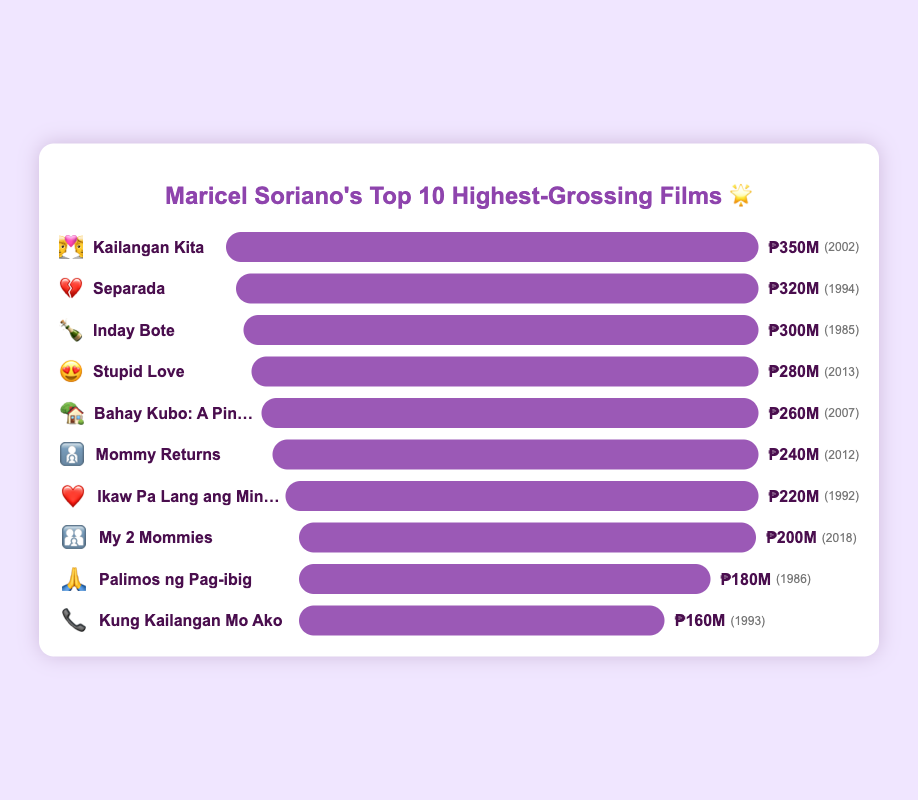Which film has the highest box office gross? The film with the highest box office gross is identified by the longest bar. "Kailangan Kita" has the longest bar with an adjusted gross of ₱350M.
Answer: "Kailangan Kita" Which film was released in 2013, and what is its box office gross? Look for the film that displays the emoji 😍 and check its gross. "Stupid Love" was released in 2013 and its gross is ₱280M.
Answer: "Stupid Love" with ₱280M Which films grossed more than ₱300M? Identify the films with bars extending beyond the ₱300M mark or whose adjusted gross values are greater than ₱300M. The films "Kailangan Kita" (₱350M), "Separada" (₱320M), and "Inday Bote" (₱300M) are the ones.
Answer: "Kailangan Kita," "Separada," and "Inday Bote" Which film has the smallest gross and what year was it released? The film with the shortest bar represents the smallest gross. "Kung Kailangan Mo Ako" has the smallest gross at ₱160M, released in 1993.
Answer: "Kung Kailangan Mo Ako," 1993 What is the combined gross of the oldest and the newest films on the chart? Identify the oldest film by the earliest year, "Inday Bote" (1985), and the newest by the most recent year, "My 2 Mommies" (2018). Sum their gross values: ₱300M + ₱200M = ₱500M.
Answer: ₱500M How many films have a box office gross between ₱200M and ₱300M? Count the films with gross values between ₱200M and ₱300M. These films are: "Stupid Love," "Bahay Kubo: A Pinoy Mano Po!," "Mommy Returns," and "Ikaw Pa Lang ang Minahal" (4 films).
Answer: 4 films Which film tells the story of a mother returning, and how much did it gross? Look for the film with the emoji 👩‍👧, which often represents a mother. "Mommy Returns" tells the story and its gross is ₱240M.
Answer: "Mommy Returns," ₱240M 